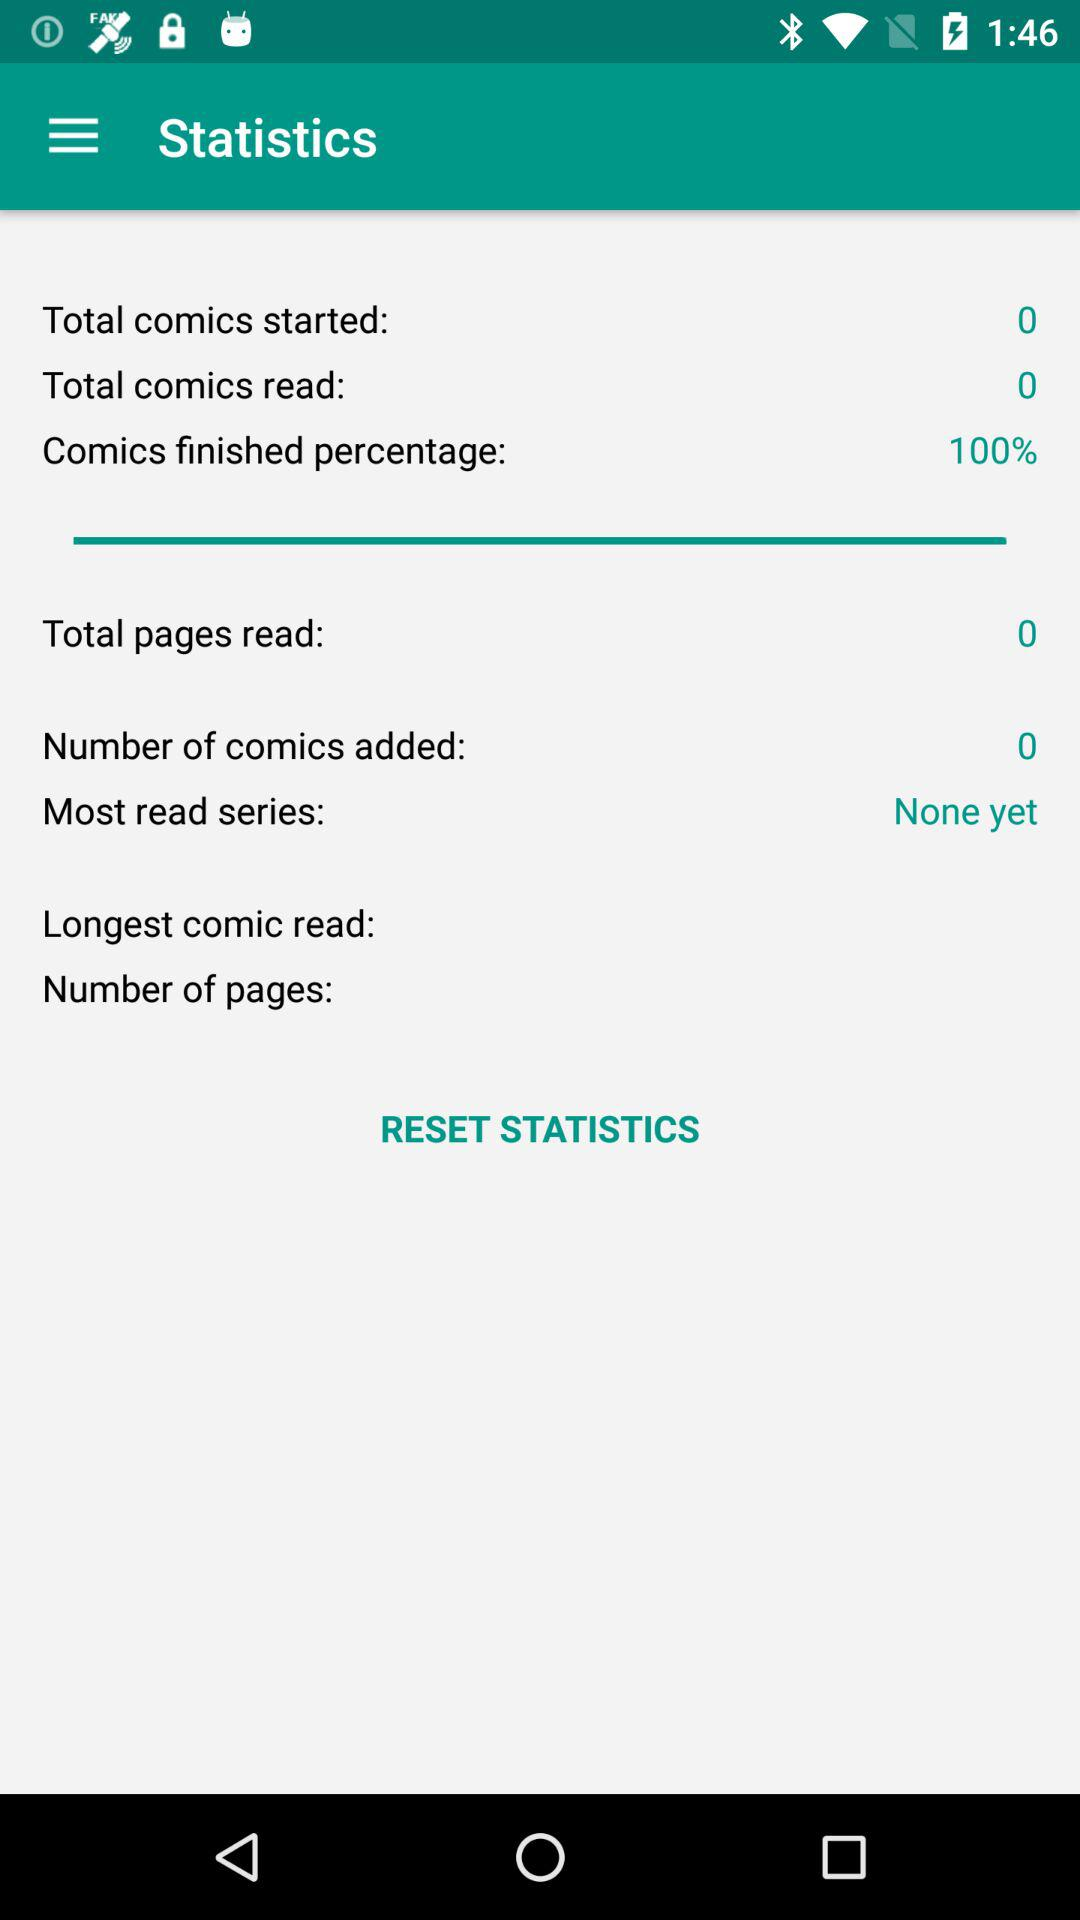What is the count of read pages? The count of read pages is 0. 